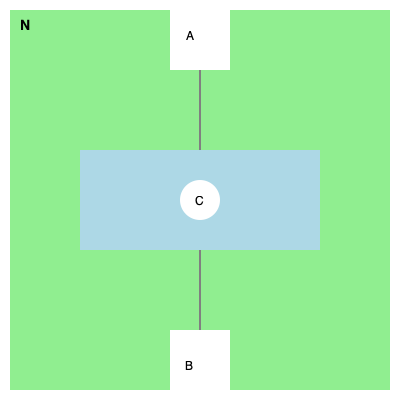Based on the simplified map of the National Mall, which historical monument or building is represented by point A, and what is its relationship to the other elements shown? To answer this question, let's analyze the map step-by-step:

1. The map shows a simplified layout of the National Mall, with north at the top of the image.

2. The large green rectangle represents the grassy areas of the National Mall.

3. The blue rectangle in the center likely represents the Reflecting Pool.

4. Point C, at the center of the map, is probably the Washington Monument, given its central location.

5. Points A and B are at opposite ends of the Mall, with A at the north end and B at the south end.

6. Given this layout, point A must represent the Lincoln Memorial. This is because:
   a) The Lincoln Memorial is located at the western end of the National Mall.
   b) It faces east towards the Washington Monument and the Capitol Building.
   c) It's positioned at one end of the Reflecting Pool.

7. By extension, point B likely represents the Capitol Building at the eastern end of the Mall.

The Lincoln Memorial's relationship to other elements:
- It's directly west of the Washington Monument (C).
- It's at the western end of the Reflecting Pool.
- It forms part of the iconic east-west axis of the National Mall, along with the Washington Monument and the Capitol Building.
Answer: Lincoln Memorial 